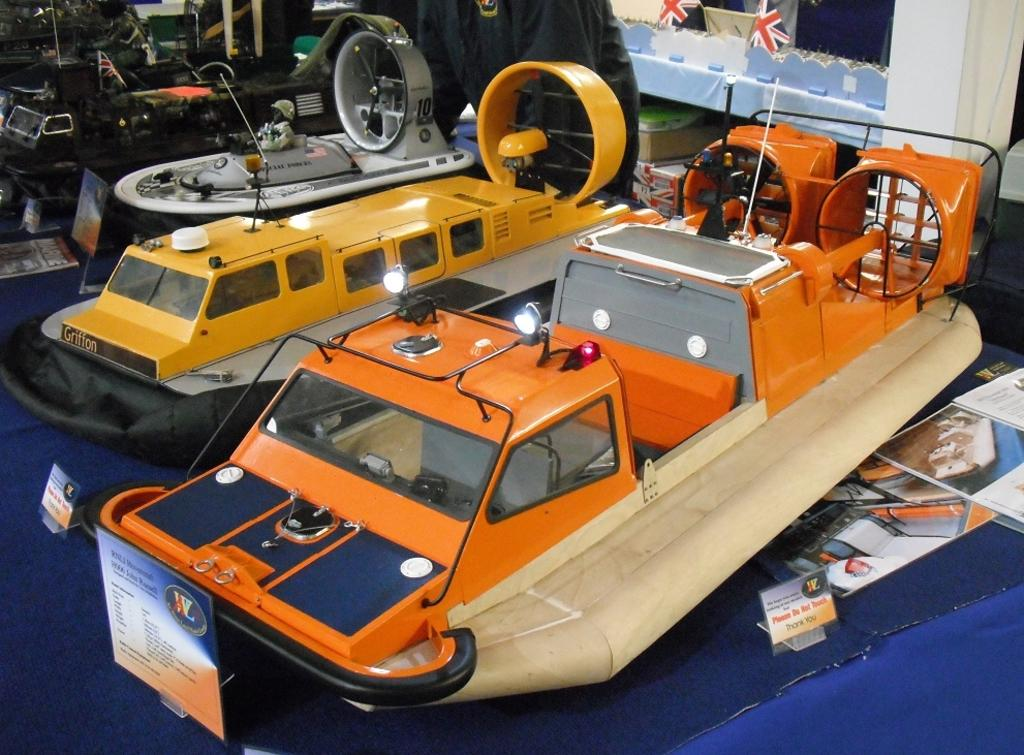What type of vehicles are in the image? There are small boats in the image. What else can be seen in the image besides the boats? There are posters, boards on a stand, a book on a platform, and persons in the background of the image. What is on the platform in the background of the image? There are flags on a platform in the background of the image. Can you describe the objects visible in the background of the image? There are other objects visible in the background of the image, but their specific details are not mentioned in the provided facts. What invention is being showcased in the library in the image? There is no mention of a library or any invention in the image. 